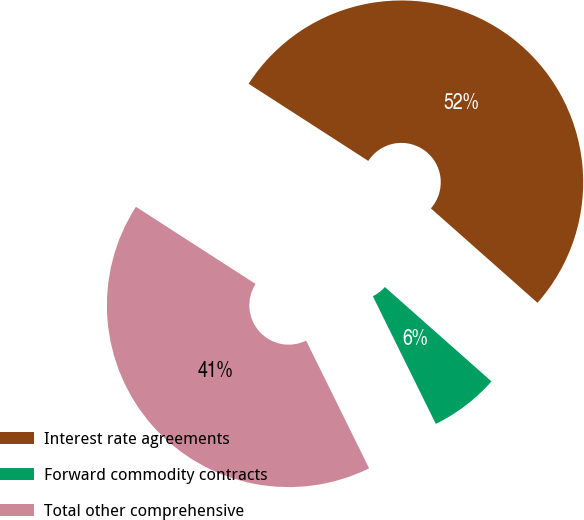Convert chart to OTSL. <chart><loc_0><loc_0><loc_500><loc_500><pie_chart><fcel>Interest rate agreements<fcel>Forward commodity contracts<fcel>Total other comprehensive<nl><fcel>52.42%<fcel>6.17%<fcel>41.41%<nl></chart> 